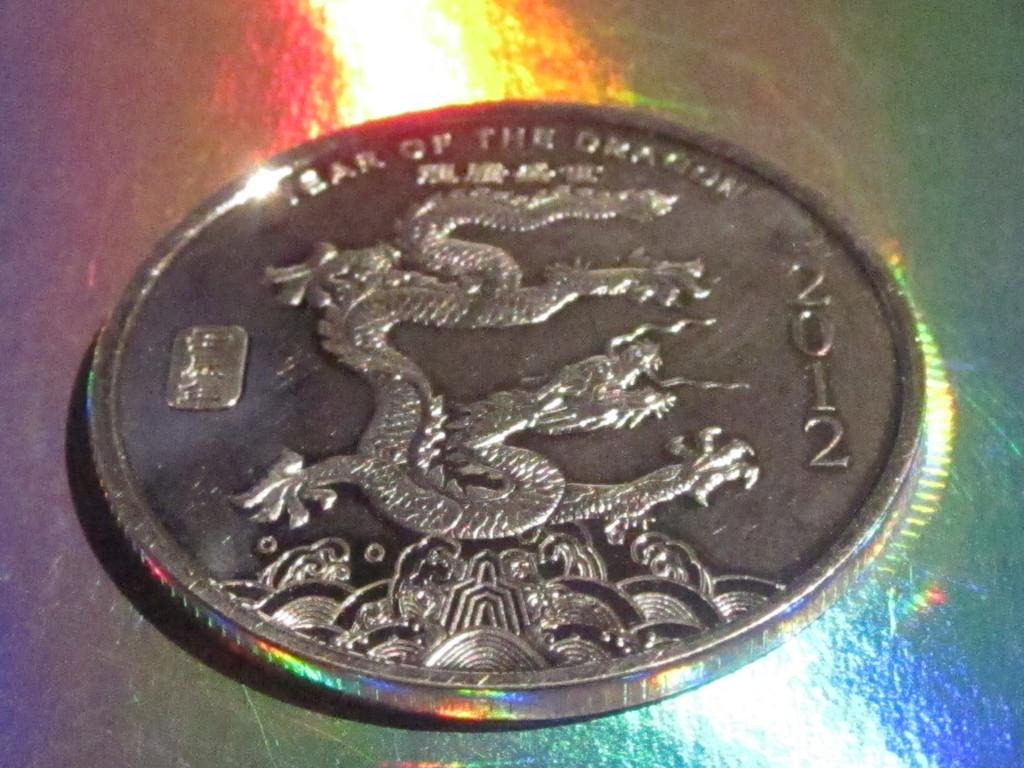2012 is the year of what?
Your response must be concise. Dragon. What year is on the coin?
Make the answer very short. 2012. 